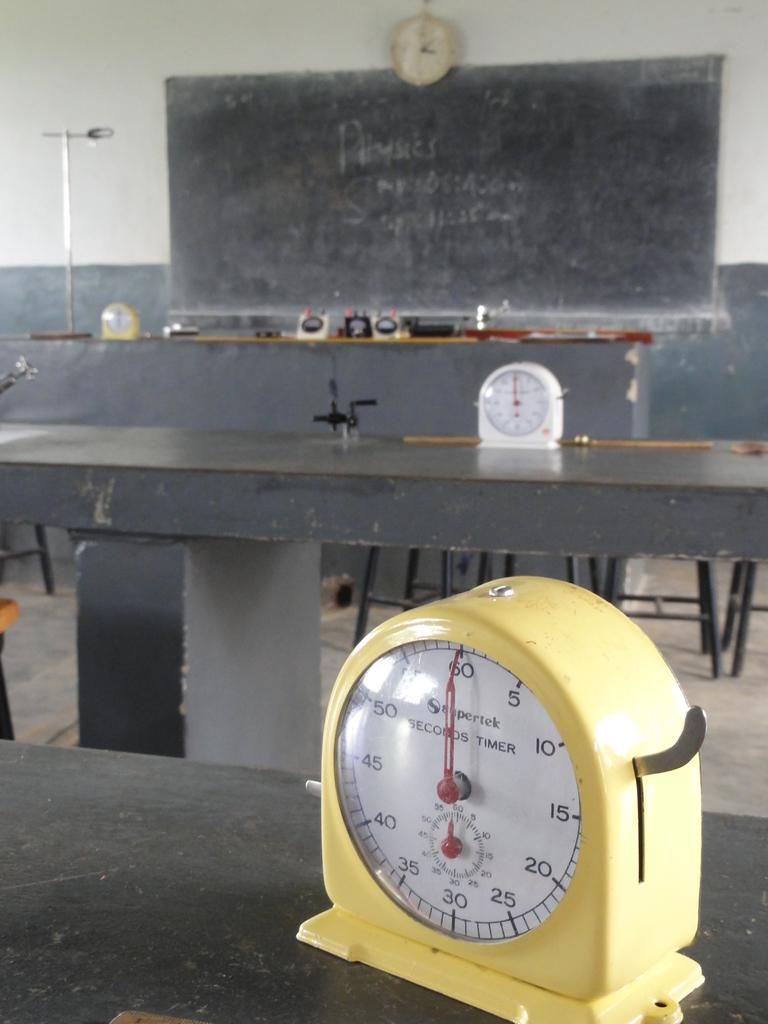<image>
Summarize the visual content of the image. A yellow timer showing the hand on 60 seconds 